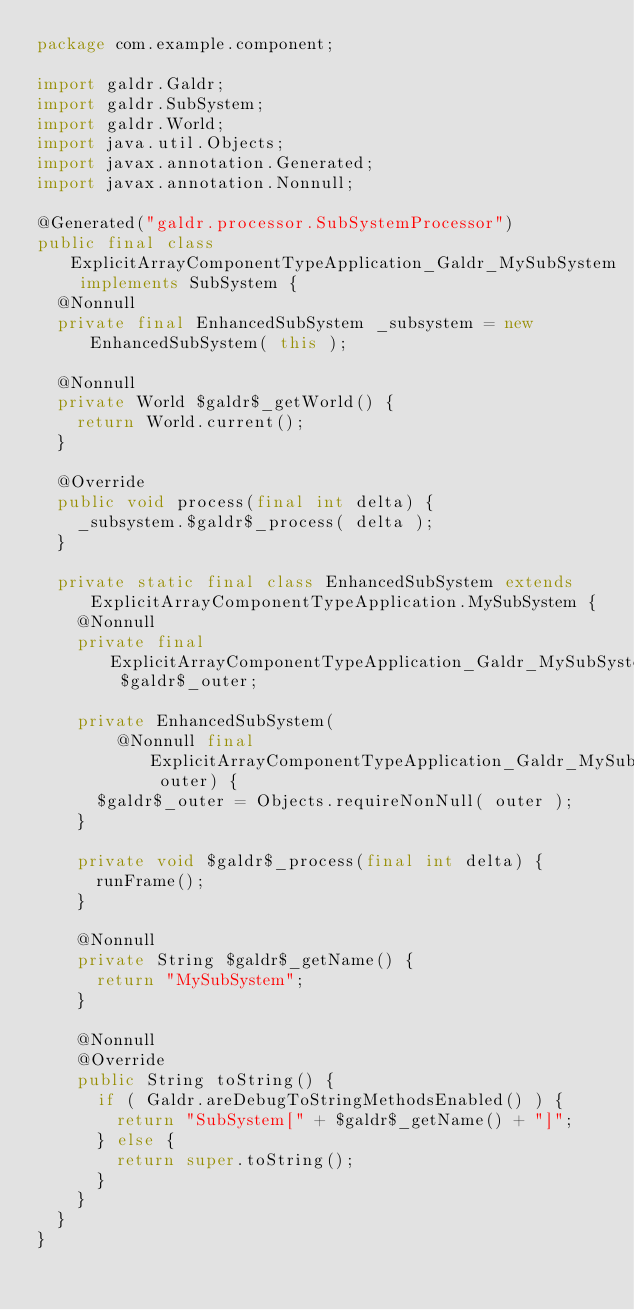Convert code to text. <code><loc_0><loc_0><loc_500><loc_500><_Java_>package com.example.component;

import galdr.Galdr;
import galdr.SubSystem;
import galdr.World;
import java.util.Objects;
import javax.annotation.Generated;
import javax.annotation.Nonnull;

@Generated("galdr.processor.SubSystemProcessor")
public final class ExplicitArrayComponentTypeApplication_Galdr_MySubSystem implements SubSystem {
  @Nonnull
  private final EnhancedSubSystem _subsystem = new EnhancedSubSystem( this );

  @Nonnull
  private World $galdr$_getWorld() {
    return World.current();
  }

  @Override
  public void process(final int delta) {
    _subsystem.$galdr$_process( delta );
  }

  private static final class EnhancedSubSystem extends ExplicitArrayComponentTypeApplication.MySubSystem {
    @Nonnull
    private final ExplicitArrayComponentTypeApplication_Galdr_MySubSystem $galdr$_outer;

    private EnhancedSubSystem(
        @Nonnull final ExplicitArrayComponentTypeApplication_Galdr_MySubSystem outer) {
      $galdr$_outer = Objects.requireNonNull( outer );
    }

    private void $galdr$_process(final int delta) {
      runFrame();
    }

    @Nonnull
    private String $galdr$_getName() {
      return "MySubSystem";
    }

    @Nonnull
    @Override
    public String toString() {
      if ( Galdr.areDebugToStringMethodsEnabled() ) {
        return "SubSystem[" + $galdr$_getName() + "]";
      } else {
        return super.toString();
      }
    }
  }
}
</code> 